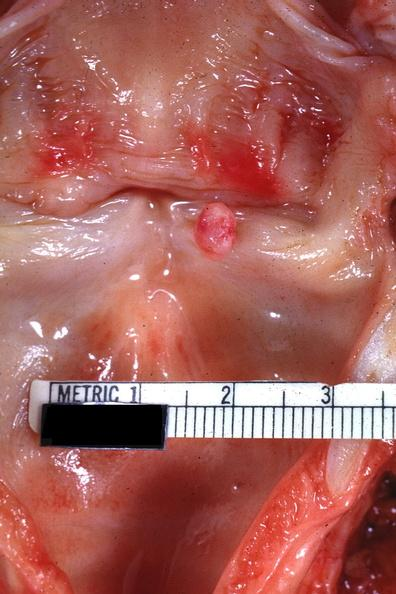what is present?
Answer the question using a single word or phrase. Larynx 